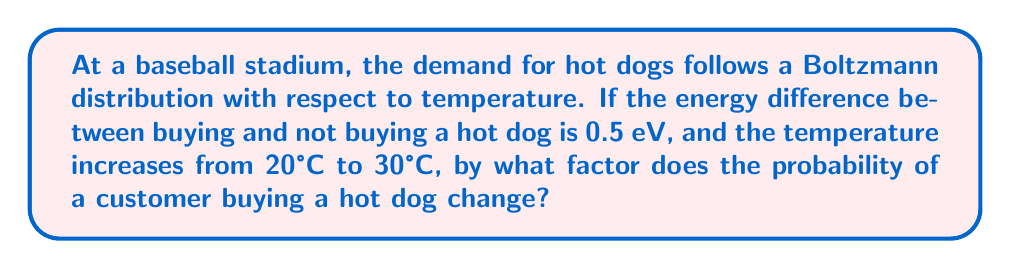Could you help me with this problem? Let's approach this step-by-step:

1) The Boltzmann distribution is given by:

   $$P \propto e^{-\frac{E}{k_B T}}$$

   where $P$ is the probability, $E$ is the energy difference, $k_B$ is the Boltzmann constant, and $T$ is the temperature in Kelvin.

2) We need to calculate the ratio of probabilities at two different temperatures:

   $$\frac{P_2}{P_1} = \frac{e^{-\frac{E}{k_B T_2}}}{e^{-\frac{E}{k_B T_1}}} = e^{\frac{E}{k_B}(\frac{1}{T_1} - \frac{1}{T_2})}$$

3) Convert temperatures from Celsius to Kelvin:
   $T_1 = 20°C + 273.15 = 293.15K$
   $T_2 = 30°C + 273.15 = 303.15K$

4) The energy difference $E = 0.5 \text{ eV}$

5) The Boltzmann constant $k_B = 8.617 \times 10^{-5} \text{ eV/K}$

6) Now, let's substitute these values into our equation:

   $$\frac{P_2}{P_1} = e^{\frac{0.5}{8.617 \times 10^{-5}}(\frac{1}{293.15} - \frac{1}{303.15})}$$

7) Simplify:
   $$\frac{P_2}{P_1} = e^{5802.48(0.00341121 - 0.00329870)} = e^{0.06542} = 1.0676$$

Therefore, the probability increases by a factor of approximately 1.0676.
Answer: 1.0676 